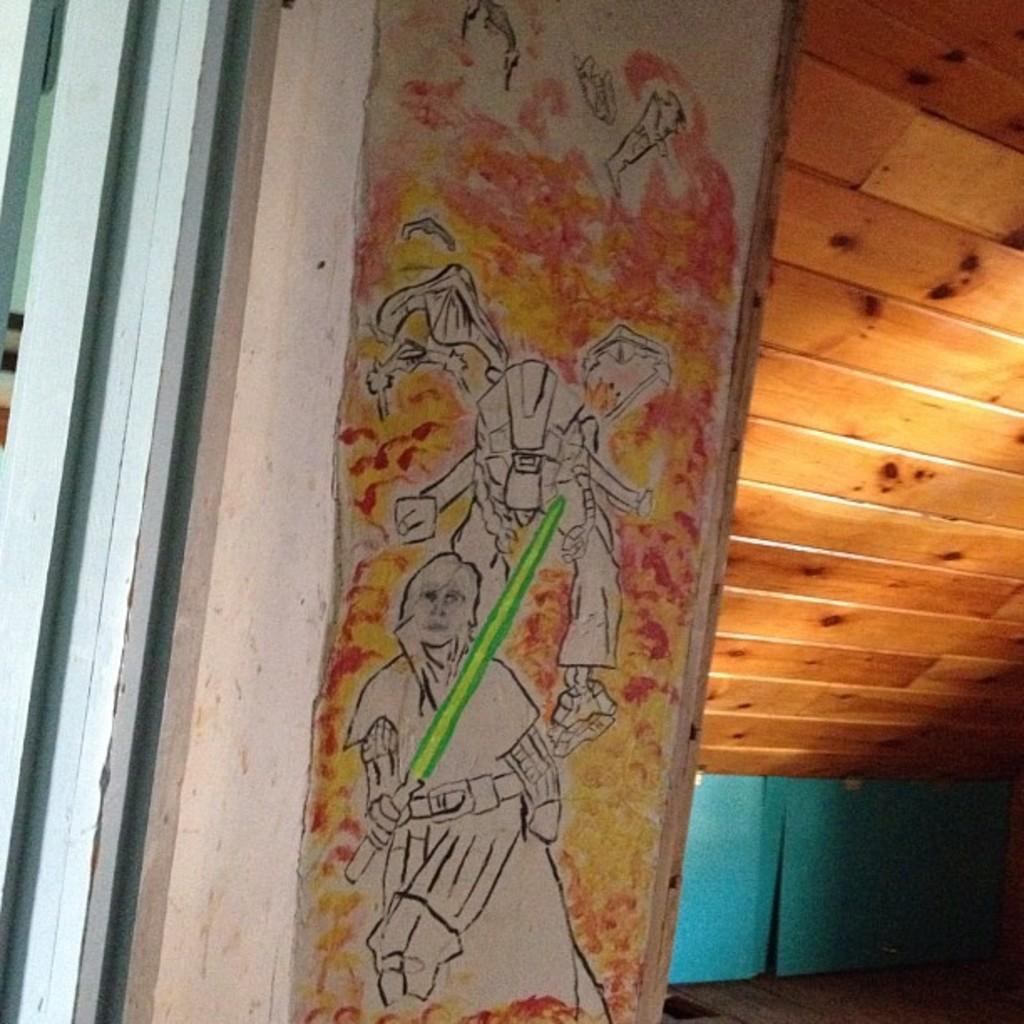In one or two sentences, can you explain what this image depicts? This image consists of a wall on which there is a painting. On the right, we can see a roof made up of wood and a wall in green color. 